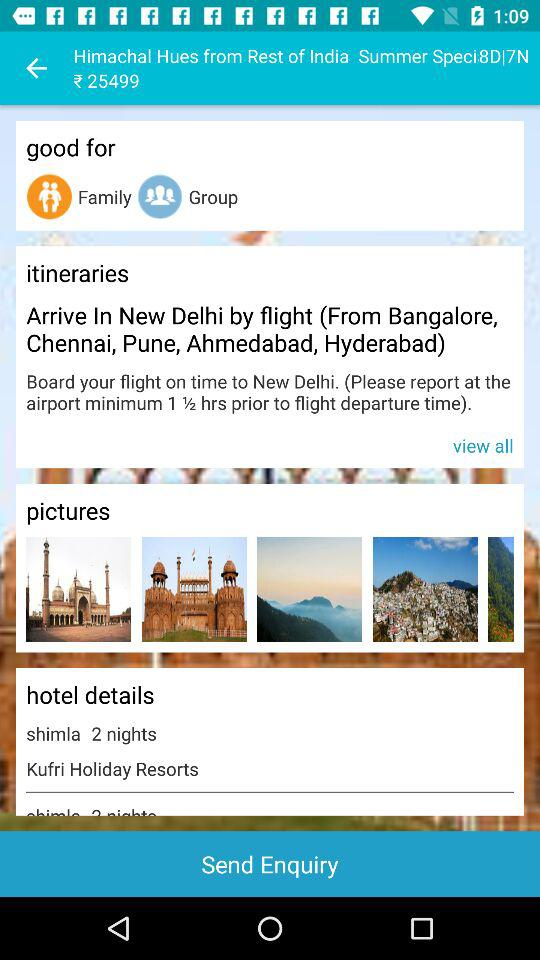For how many nights can the hotel be booked? The hotel can be booked for 2 nights. 